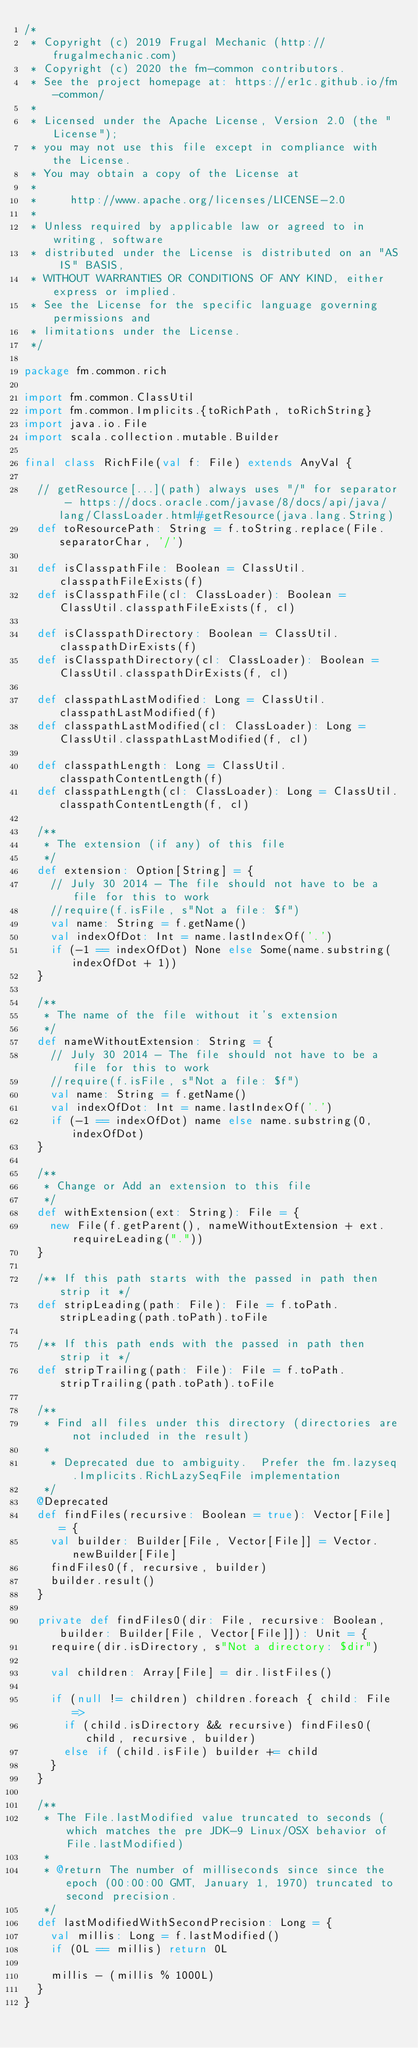<code> <loc_0><loc_0><loc_500><loc_500><_Scala_>/*
 * Copyright (c) 2019 Frugal Mechanic (http://frugalmechanic.com)
 * Copyright (c) 2020 the fm-common contributors.
 * See the project homepage at: https://er1c.github.io/fm-common/
 *
 * Licensed under the Apache License, Version 2.0 (the "License");
 * you may not use this file except in compliance with the License.
 * You may obtain a copy of the License at
 *
 *     http://www.apache.org/licenses/LICENSE-2.0
 *
 * Unless required by applicable law or agreed to in writing, software
 * distributed under the License is distributed on an "AS IS" BASIS,
 * WITHOUT WARRANTIES OR CONDITIONS OF ANY KIND, either express or implied.
 * See the License for the specific language governing permissions and
 * limitations under the License.
 */

package fm.common.rich

import fm.common.ClassUtil
import fm.common.Implicits.{toRichPath, toRichString}
import java.io.File
import scala.collection.mutable.Builder

final class RichFile(val f: File) extends AnyVal {

  // getResource[...](path) always uses "/" for separator - https://docs.oracle.com/javase/8/docs/api/java/lang/ClassLoader.html#getResource(java.lang.String)
  def toResourcePath: String = f.toString.replace(File.separatorChar, '/')

  def isClasspathFile: Boolean = ClassUtil.classpathFileExists(f)
  def isClasspathFile(cl: ClassLoader): Boolean = ClassUtil.classpathFileExists(f, cl)

  def isClasspathDirectory: Boolean = ClassUtil.classpathDirExists(f)
  def isClasspathDirectory(cl: ClassLoader): Boolean = ClassUtil.classpathDirExists(f, cl)

  def classpathLastModified: Long = ClassUtil.classpathLastModified(f)
  def classpathLastModified(cl: ClassLoader): Long = ClassUtil.classpathLastModified(f, cl)

  def classpathLength: Long = ClassUtil.classpathContentLength(f)
  def classpathLength(cl: ClassLoader): Long = ClassUtil.classpathContentLength(f, cl)

  /**
   * The extension (if any) of this file
   */
  def extension: Option[String] = {
    // July 30 2014 - The file should not have to be a file for this to work
    //require(f.isFile, s"Not a file: $f")
    val name: String = f.getName()
    val indexOfDot: Int = name.lastIndexOf('.')
    if (-1 == indexOfDot) None else Some(name.substring(indexOfDot + 1))
  }

  /**
   * The name of the file without it's extension
   */
  def nameWithoutExtension: String = {
    // July 30 2014 - The file should not have to be a file for this to work
    //require(f.isFile, s"Not a file: $f")
    val name: String = f.getName()
    val indexOfDot: Int = name.lastIndexOf('.')
    if (-1 == indexOfDot) name else name.substring(0, indexOfDot)
  }

  /**
   * Change or Add an extension to this file
   */
  def withExtension(ext: String): File = {
    new File(f.getParent(), nameWithoutExtension + ext.requireLeading("."))
  }

  /** If this path starts with the passed in path then strip it */
  def stripLeading(path: File): File = f.toPath.stripLeading(path.toPath).toFile

  /** If this path ends with the passed in path then strip it */
  def stripTrailing(path: File): File = f.toPath.stripTrailing(path.toPath).toFile

  /**
   * Find all files under this directory (directories are not included in the result)
   *
    * Deprecated due to ambiguity.  Prefer the fm.lazyseq.Implicits.RichLazySeqFile implementation
   */
  @Deprecated
  def findFiles(recursive: Boolean = true): Vector[File] = {
    val builder: Builder[File, Vector[File]] = Vector.newBuilder[File]
    findFiles0(f, recursive, builder)
    builder.result()
  }

  private def findFiles0(dir: File, recursive: Boolean, builder: Builder[File, Vector[File]]): Unit = {
    require(dir.isDirectory, s"Not a directory: $dir")

    val children: Array[File] = dir.listFiles()

    if (null != children) children.foreach { child: File =>
      if (child.isDirectory && recursive) findFiles0(child, recursive, builder)
      else if (child.isFile) builder += child
    }
  }

  /**
   * The File.lastModified value truncated to seconds (which matches the pre JDK-9 Linux/OSX behavior of File.lastModified)
   *
   * @return The number of milliseconds since since the epoch (00:00:00 GMT, January 1, 1970) truncated to second precision.
   */
  def lastModifiedWithSecondPrecision: Long = {
    val millis: Long = f.lastModified()
    if (0L == millis) return 0L

    millis - (millis % 1000L)
  }
}
</code> 